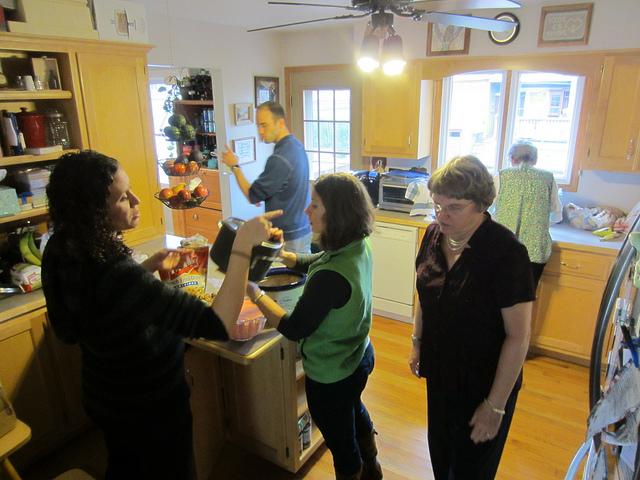What color is the tracksuit?
Be succinct. Black. How many women are in the room?
Short answer required. 4. Is this a store or home?
Give a very brief answer. Home. What dessert is the lady serving?
Give a very brief answer. Cake. What is on the ceiling?
Be succinct. Fan. 